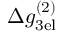Convert formula to latex. <formula><loc_0><loc_0><loc_500><loc_500>\Delta g _ { 3 e l } ^ { ( 2 ) }</formula> 